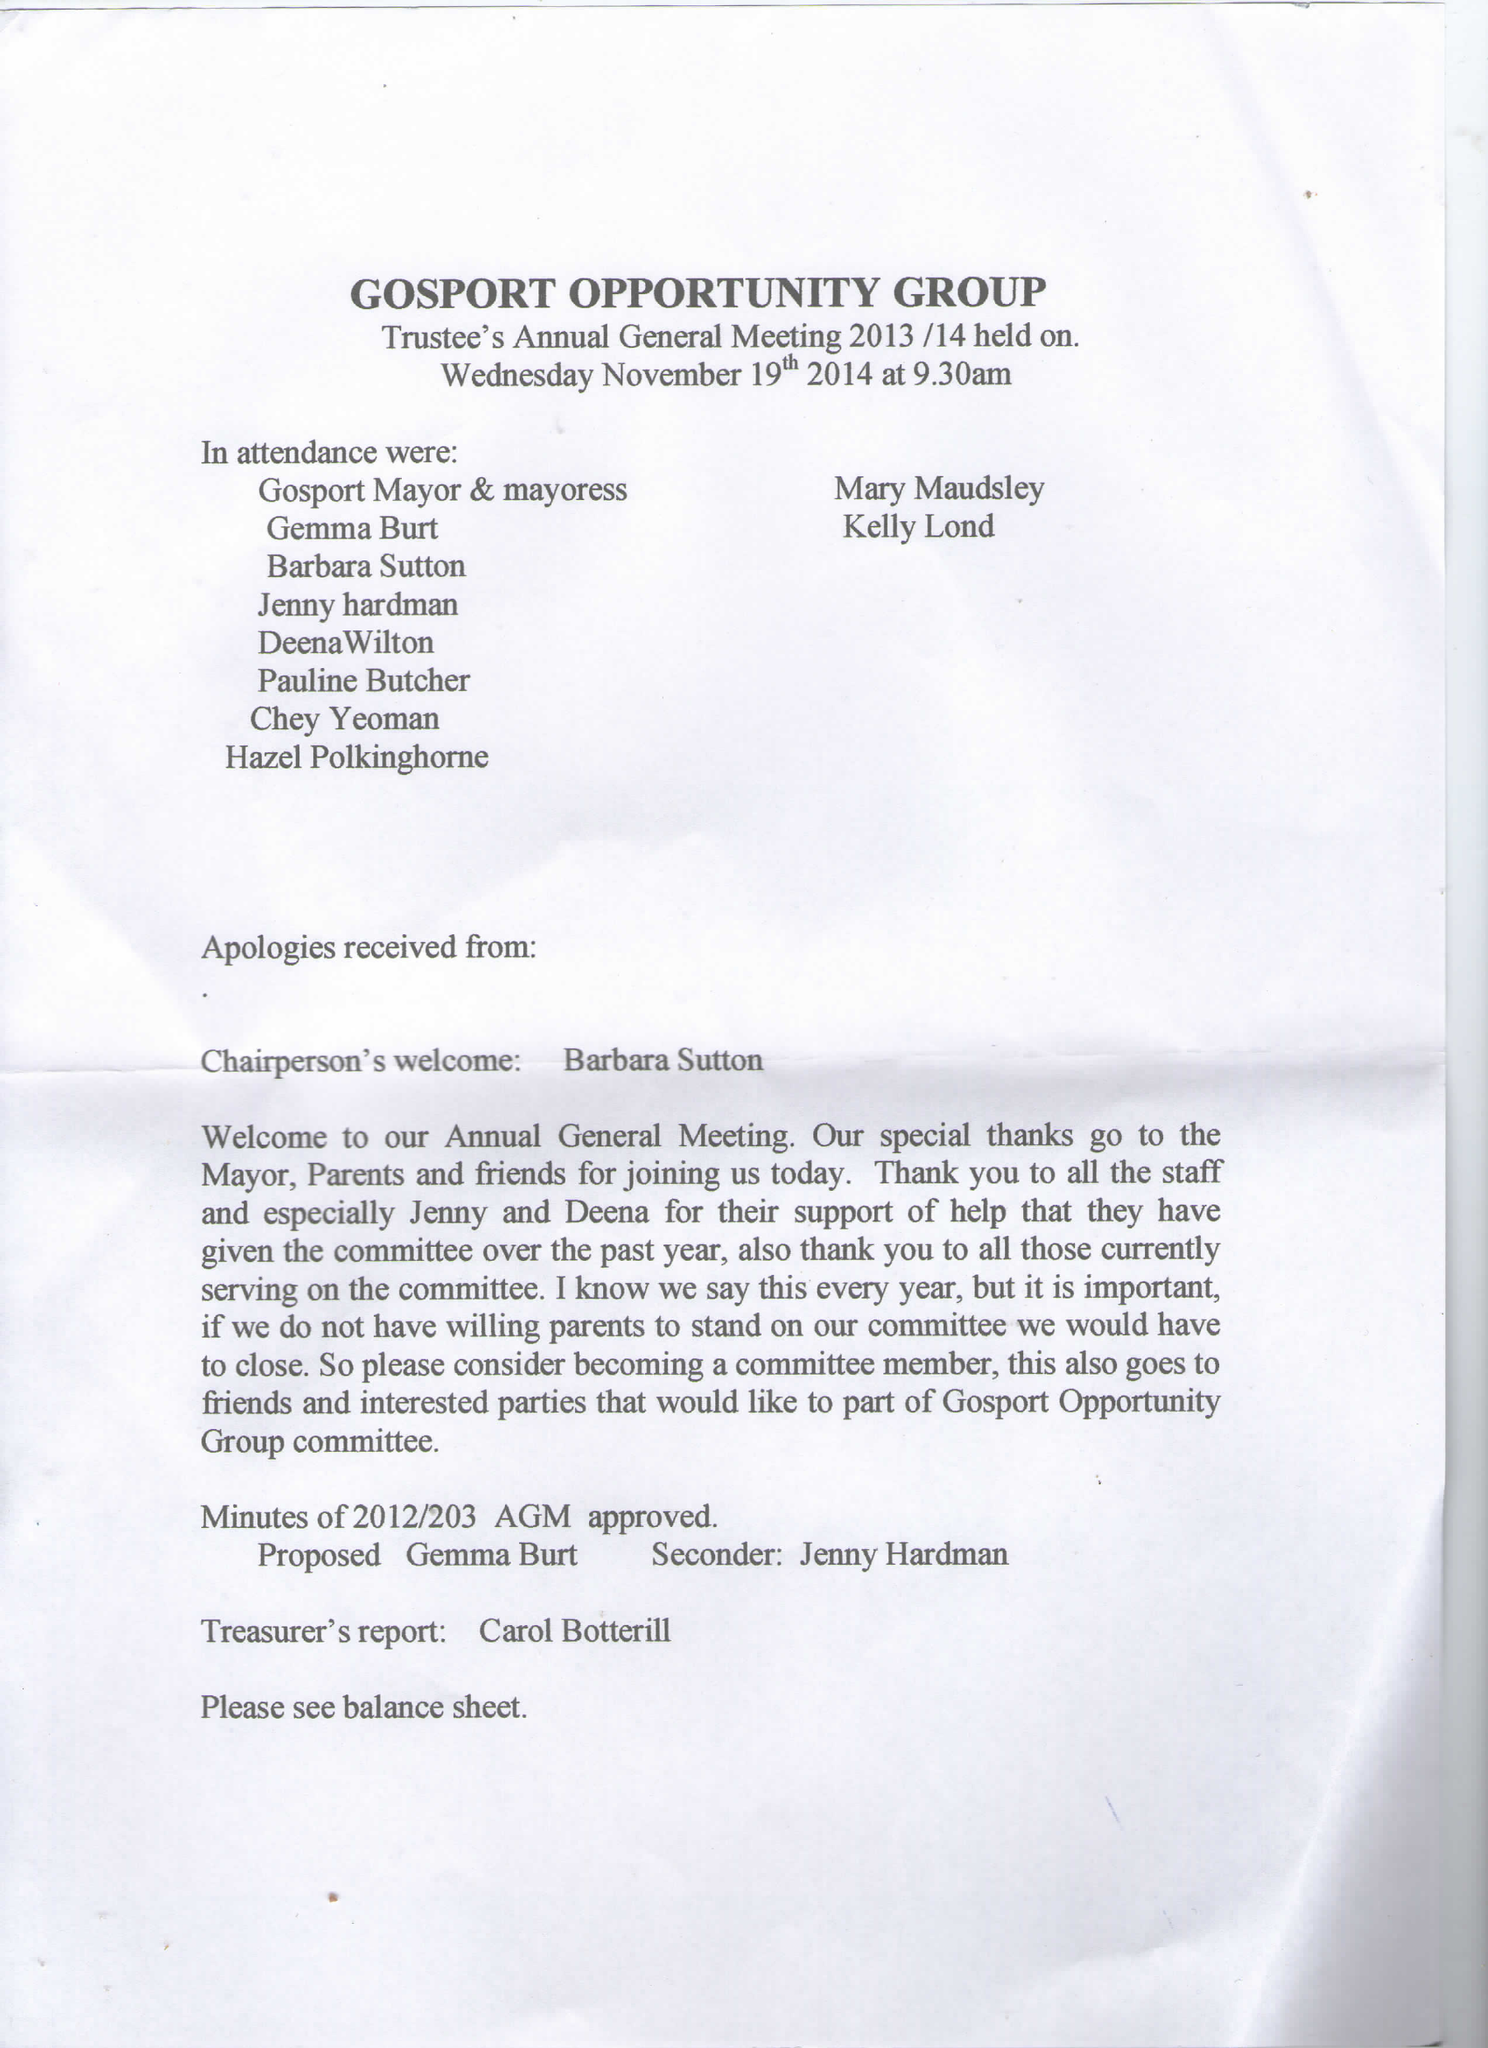What is the value for the charity_number?
Answer the question using a single word or phrase. 299388 